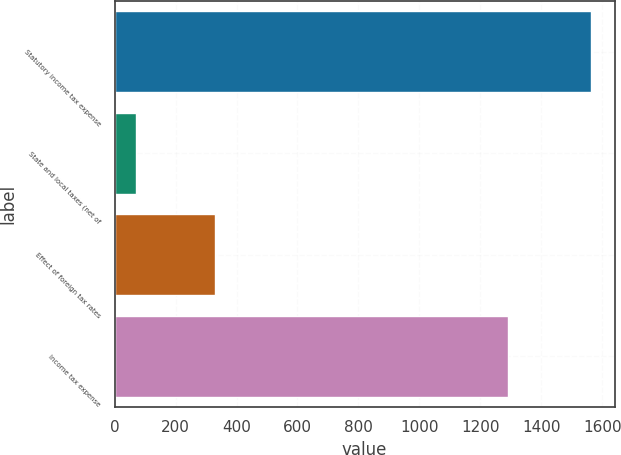Convert chart to OTSL. <chart><loc_0><loc_0><loc_500><loc_500><bar_chart><fcel>Statutory income tax expense<fcel>State and local taxes (net of<fcel>Effect of foreign tax rates<fcel>Income tax expense<nl><fcel>1562<fcel>69<fcel>329<fcel>1290<nl></chart> 